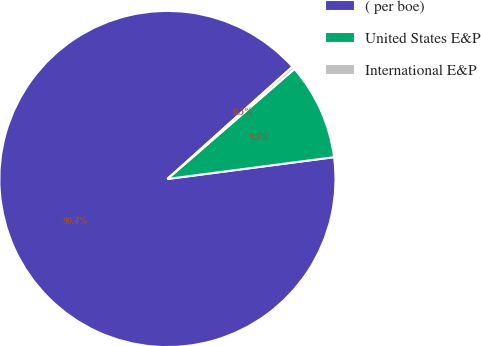Convert chart to OTSL. <chart><loc_0><loc_0><loc_500><loc_500><pie_chart><fcel>( per boe)<fcel>United States E&P<fcel>International E&P<nl><fcel>90.43%<fcel>9.29%<fcel>0.28%<nl></chart> 